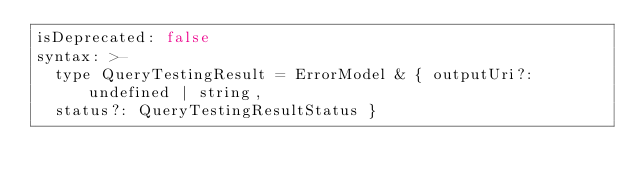<code> <loc_0><loc_0><loc_500><loc_500><_YAML_>isDeprecated: false
syntax: >-
  type QueryTestingResult = ErrorModel & { outputUri?: undefined | string,
  status?: QueryTestingResultStatus }
</code> 